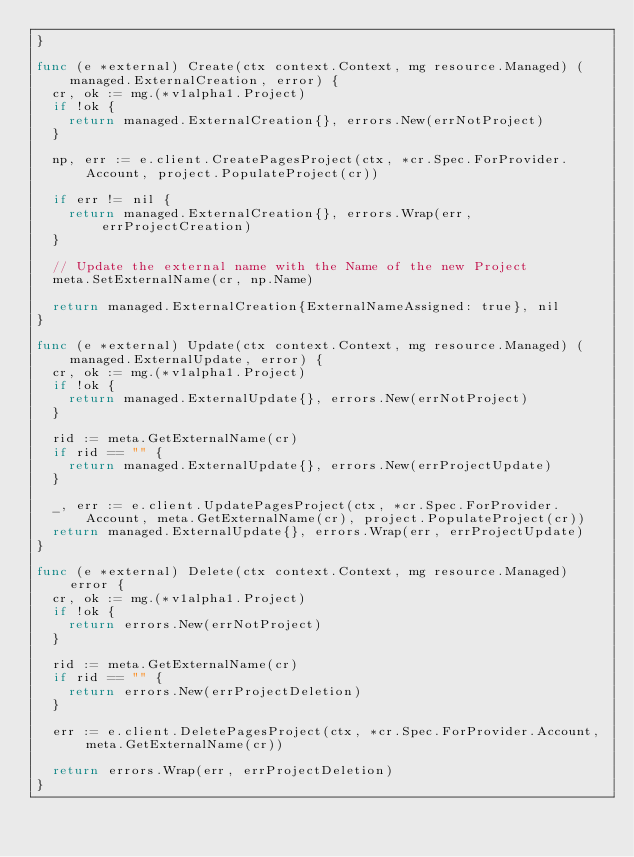<code> <loc_0><loc_0><loc_500><loc_500><_Go_>}

func (e *external) Create(ctx context.Context, mg resource.Managed) (managed.ExternalCreation, error) {
	cr, ok := mg.(*v1alpha1.Project)
	if !ok {
		return managed.ExternalCreation{}, errors.New(errNotProject)
	}

	np, err := e.client.CreatePagesProject(ctx, *cr.Spec.ForProvider.Account, project.PopulateProject(cr))

	if err != nil {
		return managed.ExternalCreation{}, errors.Wrap(err, errProjectCreation)
	}

	// Update the external name with the Name of the new Project
	meta.SetExternalName(cr, np.Name)

	return managed.ExternalCreation{ExternalNameAssigned: true}, nil
}

func (e *external) Update(ctx context.Context, mg resource.Managed) (managed.ExternalUpdate, error) {
	cr, ok := mg.(*v1alpha1.Project)
	if !ok {
		return managed.ExternalUpdate{}, errors.New(errNotProject)
	}

	rid := meta.GetExternalName(cr)
	if rid == "" {
		return managed.ExternalUpdate{}, errors.New(errProjectUpdate)
	}

	_, err := e.client.UpdatePagesProject(ctx, *cr.Spec.ForProvider.Account, meta.GetExternalName(cr), project.PopulateProject(cr))
	return managed.ExternalUpdate{}, errors.Wrap(err, errProjectUpdate)
}

func (e *external) Delete(ctx context.Context, mg resource.Managed) error {
	cr, ok := mg.(*v1alpha1.Project)
	if !ok {
		return errors.New(errNotProject)
	}

	rid := meta.GetExternalName(cr)
	if rid == "" {
		return errors.New(errProjectDeletion)
	}

	err := e.client.DeletePagesProject(ctx, *cr.Spec.ForProvider.Account, meta.GetExternalName(cr))

	return errors.Wrap(err, errProjectDeletion)
}
</code> 